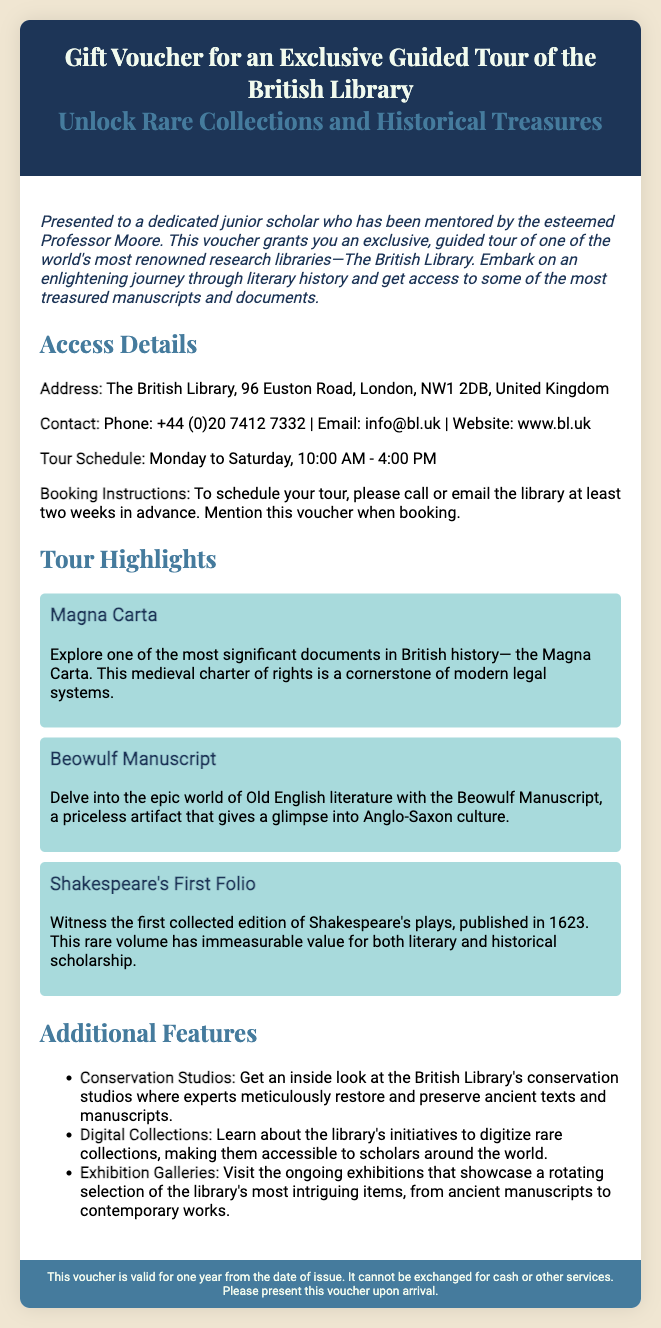what is the address of the British Library? The address is mentioned under Access Details, providing specific location information for the library.
Answer: 96 Euston Road, London, NW1 2DB, United Kingdom what is the contact number for booking the tour? The contact number is listed in the Access Details section to help users connect with the library.
Answer: +44 (0)20 7412 7332 when is the tour available? The tour schedule is detailed under Access Details, indicating specific days and times for visiting the library.
Answer: Monday to Saturday, 10:00 AM - 4:00 PM which document highlights Old English literature? This highlight discusses a specific literary artifact and its cultural significance, indicating its relevance to the topic.
Answer: Beowulf Manuscript what must be mentioned when booking the tour? This is a requirement noted in the Booking Instructions, clarifying what information should be provided for a reservation.
Answer: this voucher how long is the gift voucher valid? The validity period is stated in the footer, providing essential information about the effective use of the voucher.
Answer: one year what type of restoration can visitors see? This question touches on a feature described under Additional Features, showcasing specific activities available during the tour.
Answer: conservation studios what famous play collection is included in the tour? This highlights a significant work in literature mentioned in the Tour Highlights, showcasing its importance in education.
Answer: Shakespeare's First Folio 